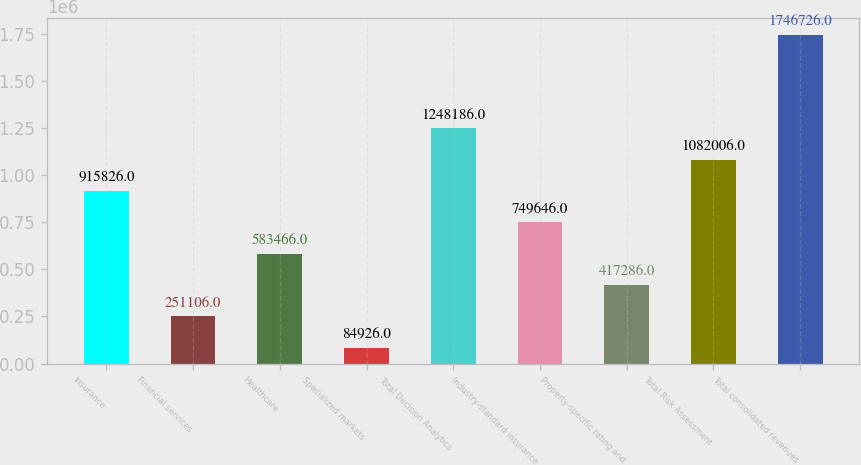Convert chart. <chart><loc_0><loc_0><loc_500><loc_500><bar_chart><fcel>Insurance<fcel>Financial services<fcel>Healthcare<fcel>Specialized markets<fcel>Total Decision Analytics<fcel>Industry-standard insurance<fcel>Property-specific rating and<fcel>Total Risk Assessment<fcel>Total consolidated revenues<nl><fcel>915826<fcel>251106<fcel>583466<fcel>84926<fcel>1.24819e+06<fcel>749646<fcel>417286<fcel>1.08201e+06<fcel>1.74673e+06<nl></chart> 